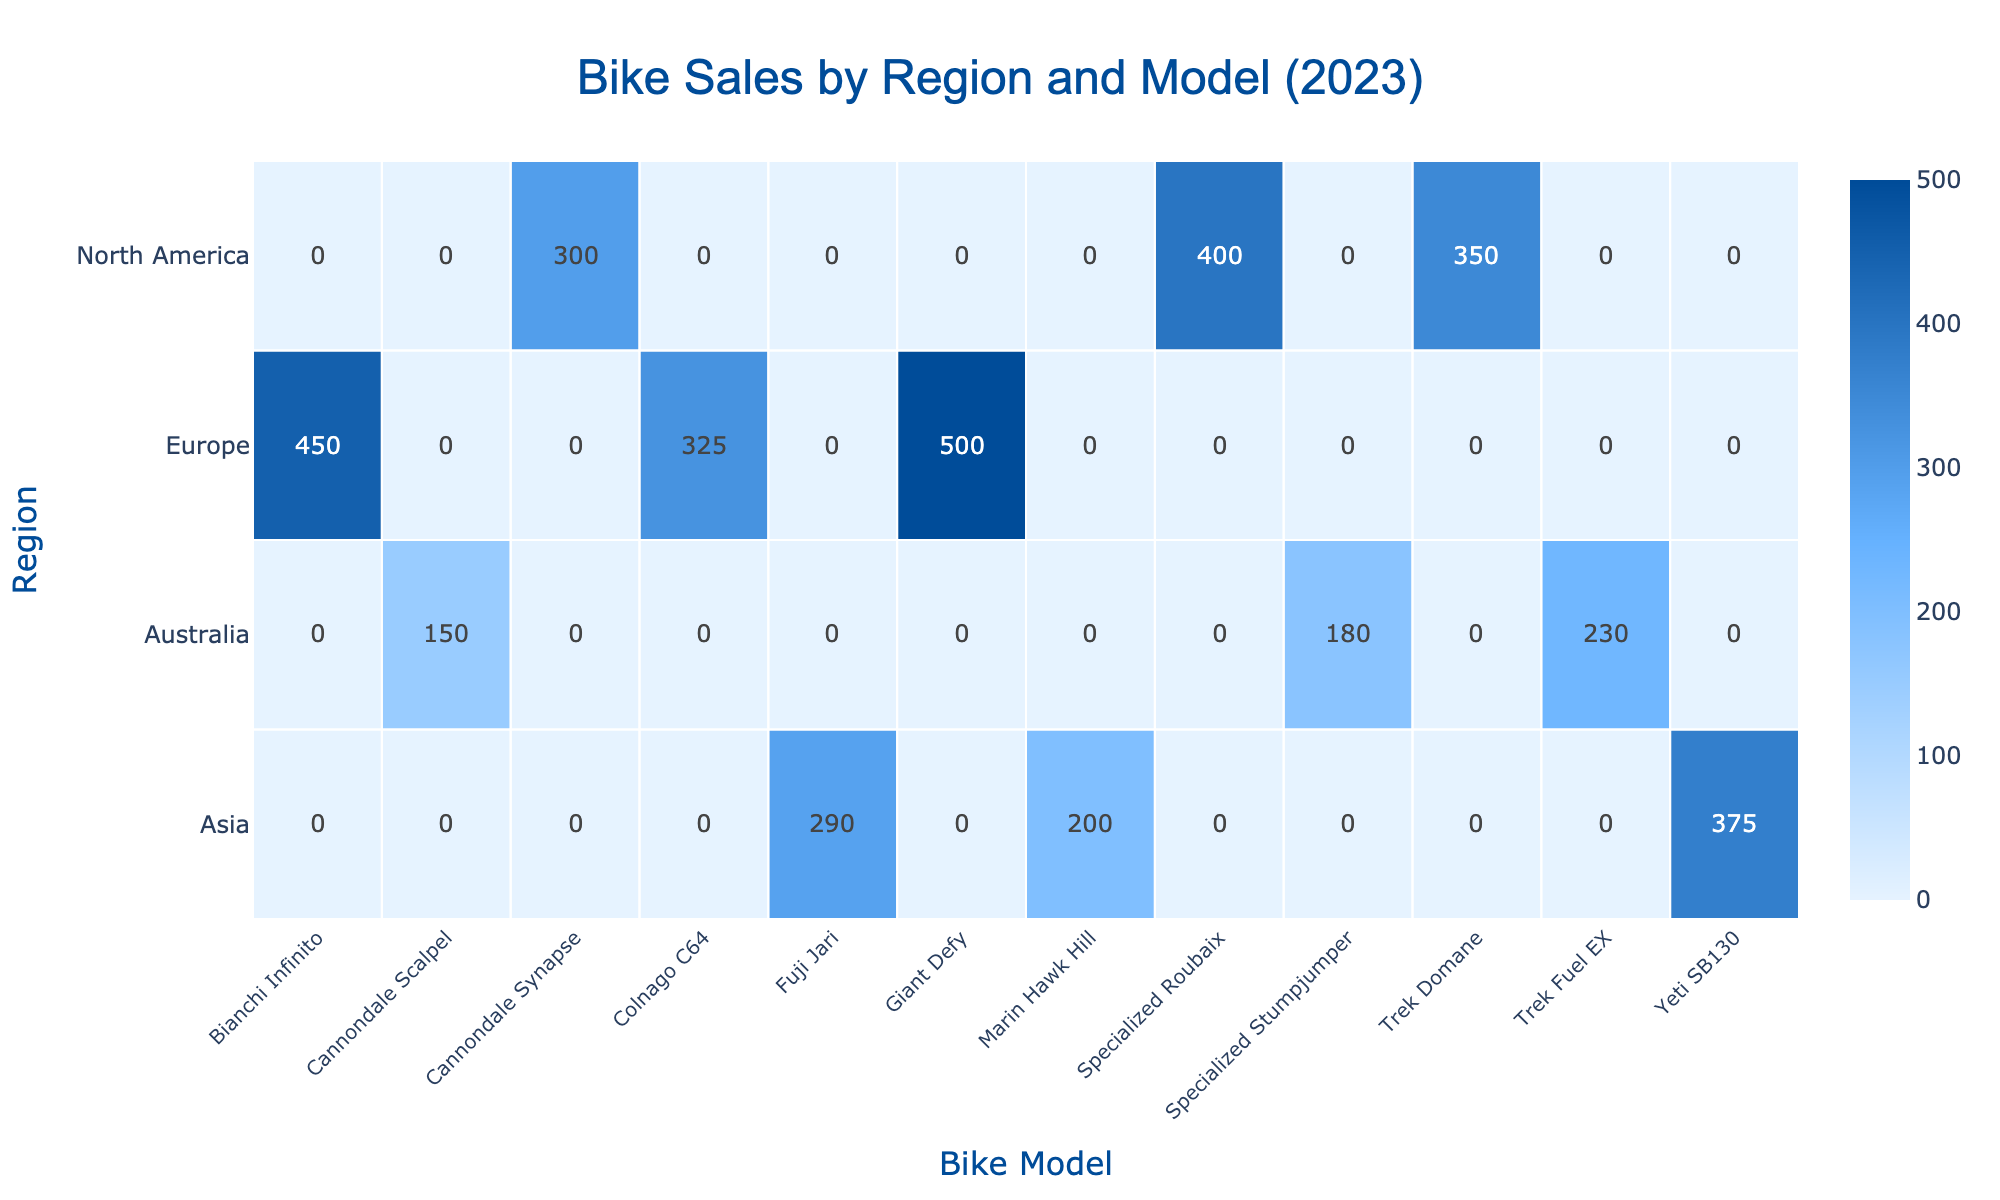What is the total sales for the Trek Domane in North America? In the table, the only entry for the Trek Domane is listed under North America with sales of 350. Thus, the total sales for the Trek Domane in this region is simply 350.
Answer: 350 Which bike model had the highest sales in Europe? By examining the sales data for Europe, the values for the models are: Giant Defy (500), Bianchi Infinito (450), and Colnago C64 (325). The highest value among these is 500 for the Giant Defy.
Answer: Giant Defy Is the total sales for Cannondale Synapse in North America greater than the total sales for Cannondale Scalpel in Australia? The Cannondale Synapse in North America has sales of 300, and the Cannondale Scalpel in Australia has sales of 150. Since 300 is greater than 150, the statement is true.
Answer: Yes What are the total sales figures for all bike models in Asia? The sales figures for bike models in Asia are: Yeti SB130 (375), Marin Hawk Hill (200), and Fuji Jari (290). Adding these values gives 375 + 200 + 290 = 865, which represents the total sales for Asia.
Answer: 865 Which region had the lowest sales for the Specialized Stumpjumper? The only sales record for the Specialized Stumpjumper is in Australia, where it has sales of 180. Since this is the only entry for that model, Australia is the region with the lowest sales for it.
Answer: Australia What is the difference in sales between the best-selling bike model in North America and the best-selling bike model in Europe? For North America, the best-selling model is the Specialized Roubaix with 400 sales. In Europe, the best-selling model is the Giant Defy with 500 sales. The difference is calculated as 500 - 400 = 100.
Answer: 100 How many bike models sold over 300 units in the Asia region? The models in Asia and their sales figures are: Yeti SB130 (375), Marin Hawk Hill (200), and Fuji Jari (290). Only the Yeti SB130 sold over 300 units, meaning there is 1 model that meets this criterion.
Answer: 1 Does Europe have any bike model sales figures less than 350? The sales figures for Europe are: Giant Defy (500), Bianchi Infinito (450), and Colnago C64 (325). Since Colnago C64 has sales of 325, which is less than 350, the statement is true.
Answer: Yes If you combine the sales of Trek Fuel EX and the Cannondale Scalpel, what is the total? The sales for Trek Fuel EX in Australia is 230, and for Cannondale Scalpel it's 150. Adding these together gives 230 + 150 = 380.
Answer: 380 